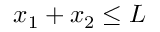Convert formula to latex. <formula><loc_0><loc_0><loc_500><loc_500>x _ { 1 } + x _ { 2 } \leq L</formula> 